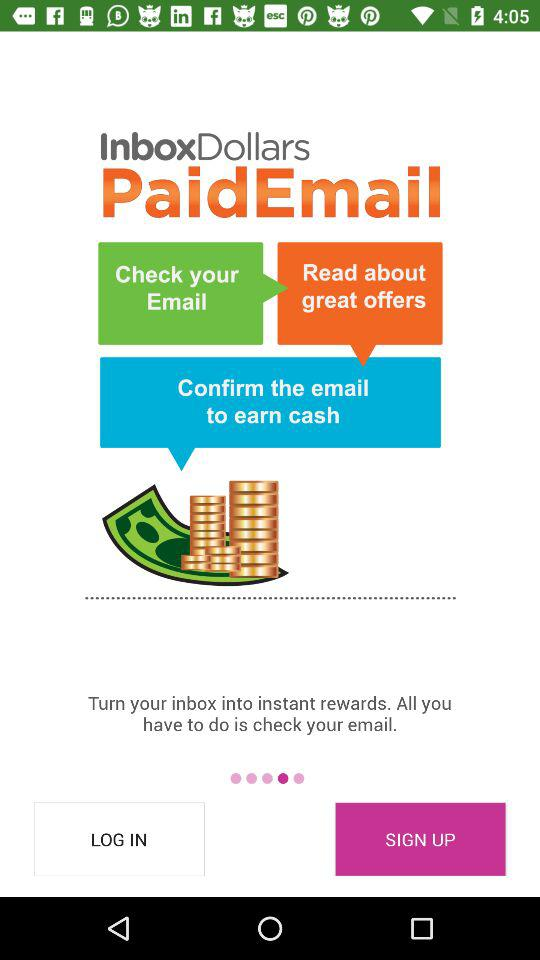What is the name of the application? The name of the application is "InboxDollars". 